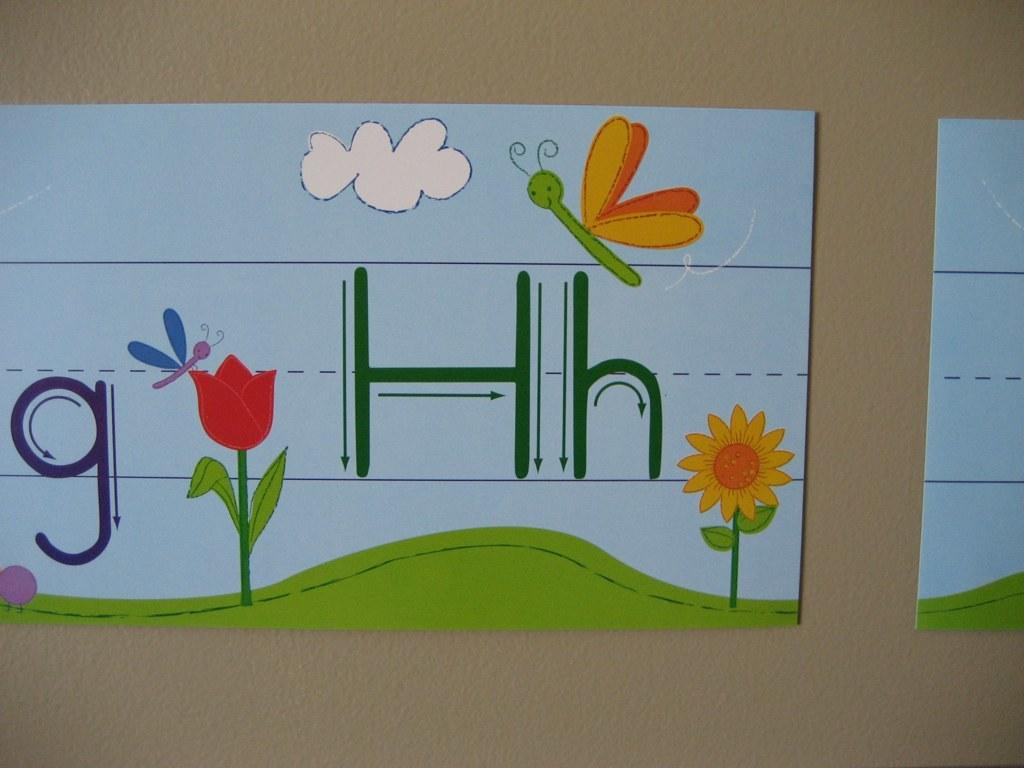What is depicted on the boards in the image? There are boards with colorful paintings in the image. Are there any words or letters on the boards? Yes, there are letters on the boards. How are the boards positioned in the image? The boards appear to be attached to a wall. How many flowers are present on the boards in the image? There are no flowers depicted on the boards in the image; they feature colorful paintings and letters. 